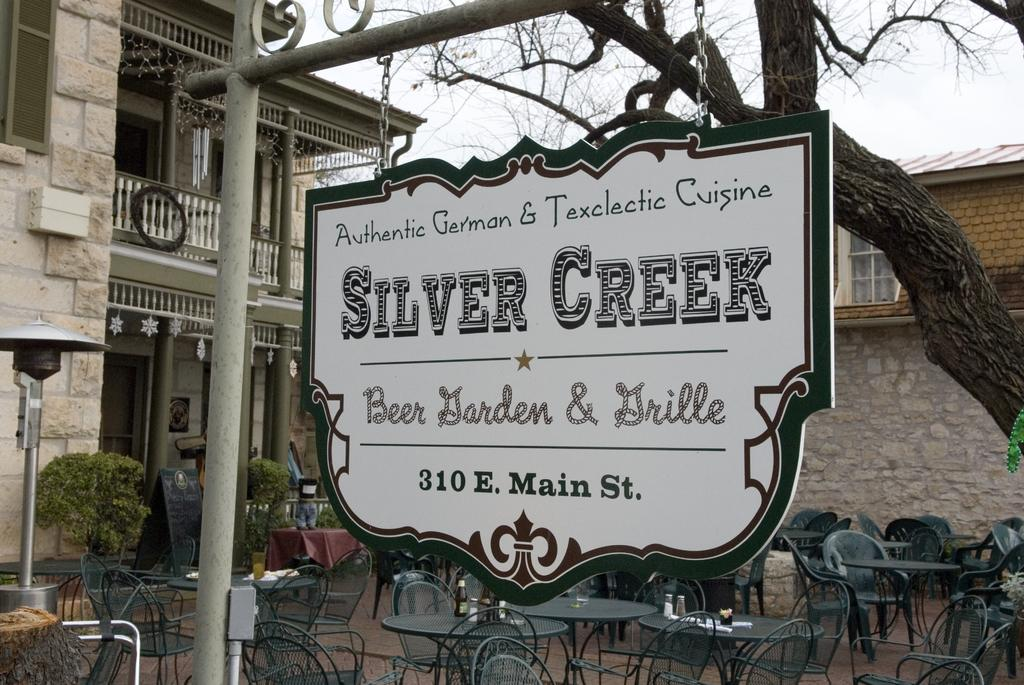What type of furniture can be seen in the image? There are chairs and tables in the image. Where are the chairs and tables located? The chairs and tables are arranged inside a building. What other objects can be seen in the image? There is a board and a tree in the image. Can you tell me how many roses are on the table in the image? There are no roses present in the image; it features chairs, tables, a board, and a tree. Is there a boy sitting on one of the chairs in the image? There is no boy present in the image; it only shows chairs, tables, a board, and a tree. 